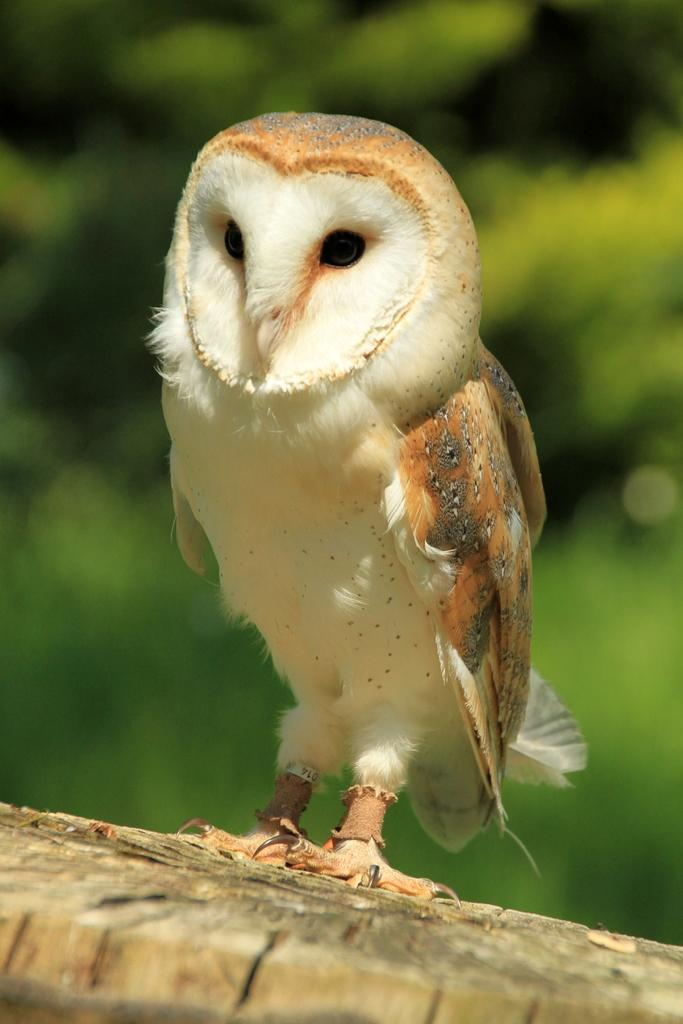What type of animal is in the image? There is an owl in the image. What is the owl sitting on? The owl is on a wooden surface. Can you describe the background of the image? The background of the image is blurred. What type of dinner is being served in the image? There is no dinner present in the image; it features an owl on a wooden surface with a blurred background. 